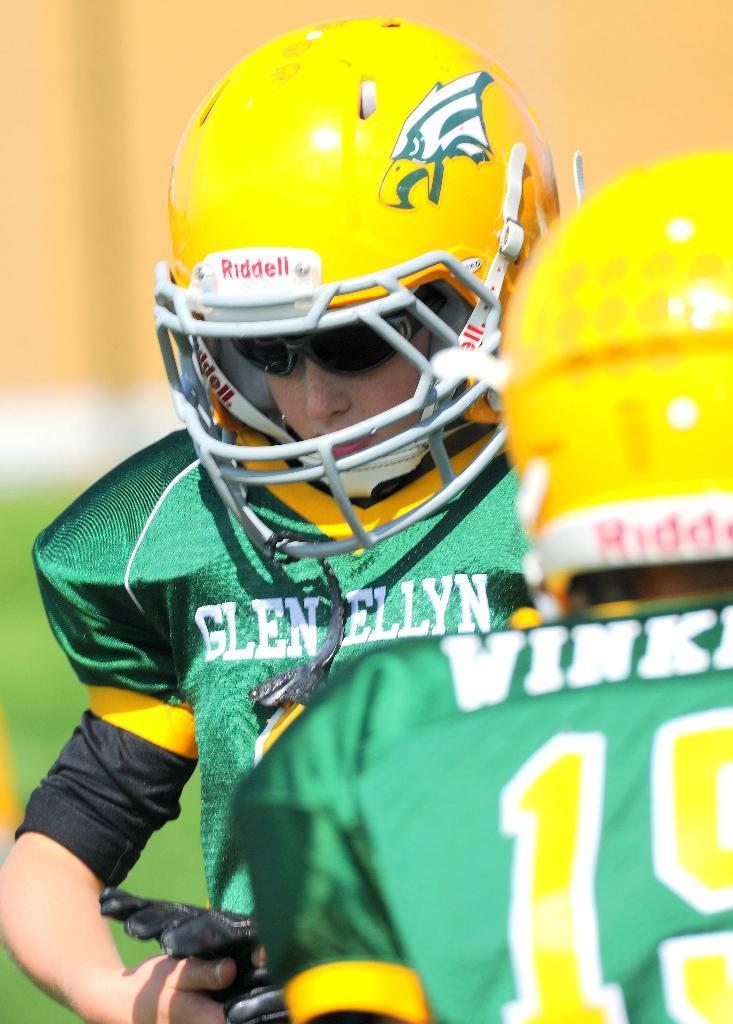How many people are in the image? There are two people in the image. What are the people doing in the image? The people are standing on the ground. What can be seen in the background of the image? There are trees in the background of the image. What type of government is depicted in the image? There is no government depicted in the image; it features two people standing on the ground with trees in the background. Can you tell me how many sticks are being used by the people in the image? There are no sticks present in the image. 